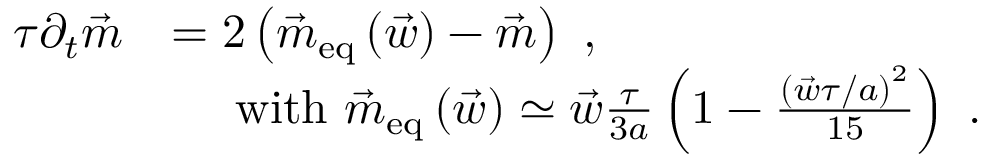Convert formula to latex. <formula><loc_0><loc_0><loc_500><loc_500>\begin{array} { r l } { \tau \partial _ { t } \vec { m } } & { = 2 \left ( \vec { m } _ { e q } \left ( \vec { w } \right ) - \vec { m } \right ) \ , } \\ & { \quad w i t h \ \vec { m } _ { e q } \left ( \vec { w } \right ) \simeq \vec { w } \frac { \tau } { 3 a } \left ( 1 - \frac { \left ( \vec { w } \tau / a \right ) ^ { 2 } } { 1 5 } \right ) \ . } \end{array}</formula> 